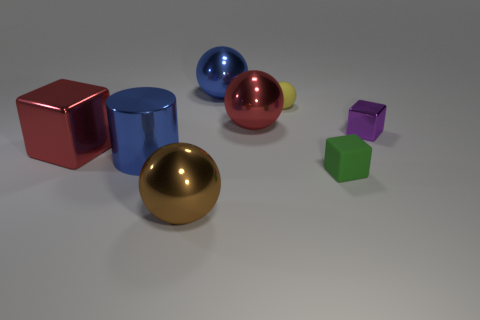Subtract all tiny green cubes. How many cubes are left? 2 Subtract all purple cubes. How many cubes are left? 2 Subtract 0 cyan cylinders. How many objects are left? 8 Subtract all cylinders. How many objects are left? 7 Subtract 1 cylinders. How many cylinders are left? 0 Subtract all cyan cubes. Subtract all blue spheres. How many cubes are left? 3 Subtract all purple cylinders. How many brown balls are left? 1 Subtract all purple metal blocks. Subtract all cylinders. How many objects are left? 6 Add 2 tiny green things. How many tiny green things are left? 3 Add 8 small green objects. How many small green objects exist? 9 